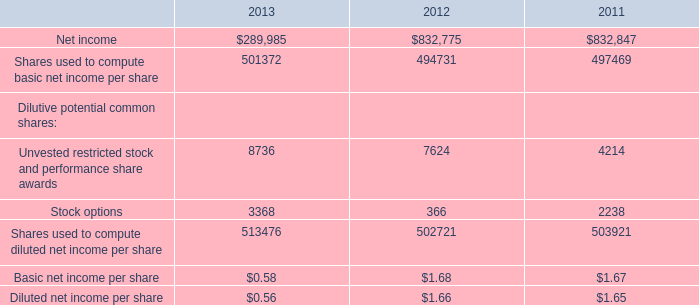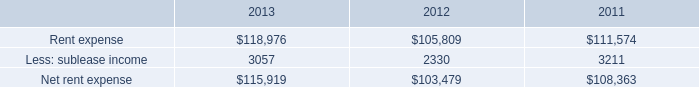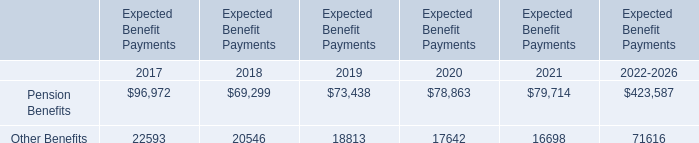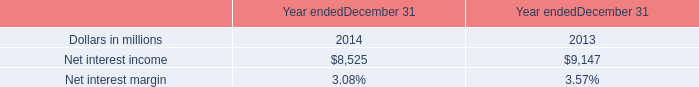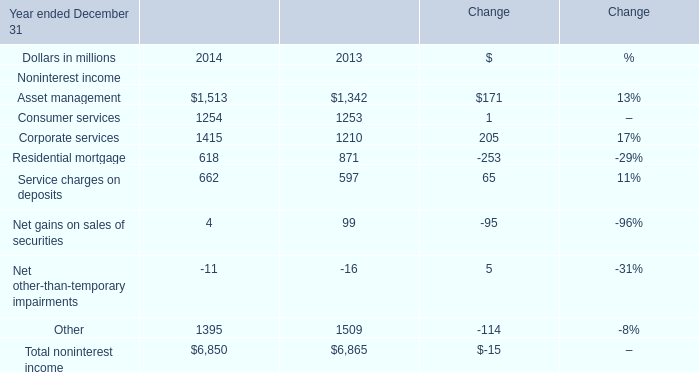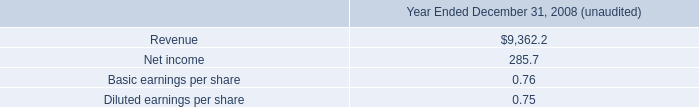In the year with largest amount of Total noninterest income, what's the sum of Other and Net other-than-temporary impairments ? (in million) 
Computations: (1509 - 16)
Answer: 1493.0. 